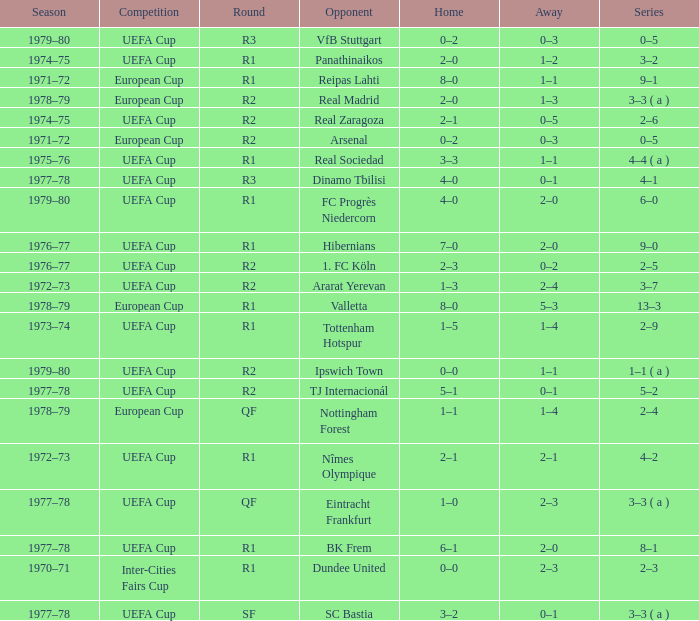Which Round has a Competition of uefa cup, and a Series of 5–2? R2. 